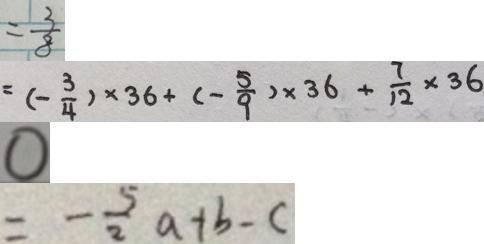<formula> <loc_0><loc_0><loc_500><loc_500>= \frac { 3 } { 8 } 
 = ( - \frac { 3 } { 4 } ) \times 3 6 + ( - \frac { 5 } { 9 } ) \times 3 6 + \frac { 7 } { 1 2 } \times 3 6 
 0 
 = - \frac { 5 } { 2 } a + b - c</formula> 